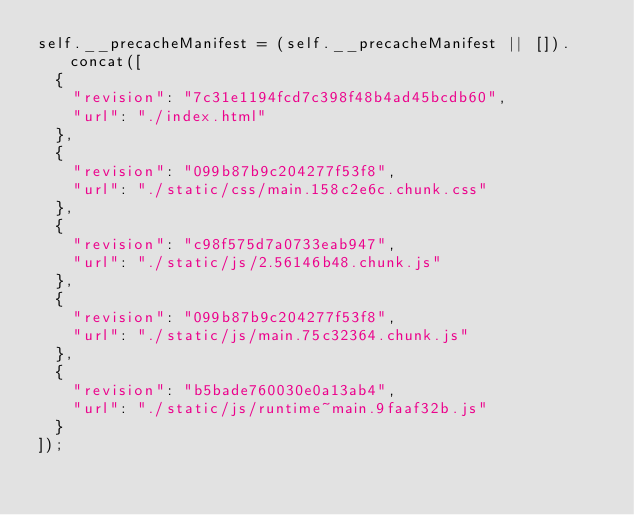Convert code to text. <code><loc_0><loc_0><loc_500><loc_500><_JavaScript_>self.__precacheManifest = (self.__precacheManifest || []).concat([
  {
    "revision": "7c31e1194fcd7c398f48b4ad45bcdb60",
    "url": "./index.html"
  },
  {
    "revision": "099b87b9c204277f53f8",
    "url": "./static/css/main.158c2e6c.chunk.css"
  },
  {
    "revision": "c98f575d7a0733eab947",
    "url": "./static/js/2.56146b48.chunk.js"
  },
  {
    "revision": "099b87b9c204277f53f8",
    "url": "./static/js/main.75c32364.chunk.js"
  },
  {
    "revision": "b5bade760030e0a13ab4",
    "url": "./static/js/runtime~main.9faaf32b.js"
  }
]);</code> 